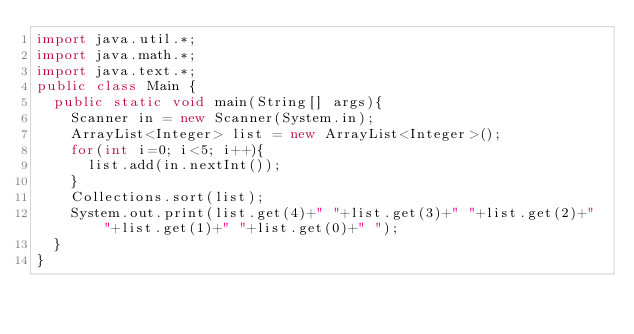Convert code to text. <code><loc_0><loc_0><loc_500><loc_500><_Java_>import java.util.*;
import java.math.*;
import java.text.*;
public class Main {
	public static void main(String[] args){
		Scanner in = new Scanner(System.in);
		ArrayList<Integer> list = new ArrayList<Integer>();
		for(int i=0; i<5; i++){
			list.add(in.nextInt());
		}
		Collections.sort(list);
		System.out.print(list.get(4)+" "+list.get(3)+" "+list.get(2)+" "+list.get(1)+" "+list.get(0)+" ");
	}
}</code> 